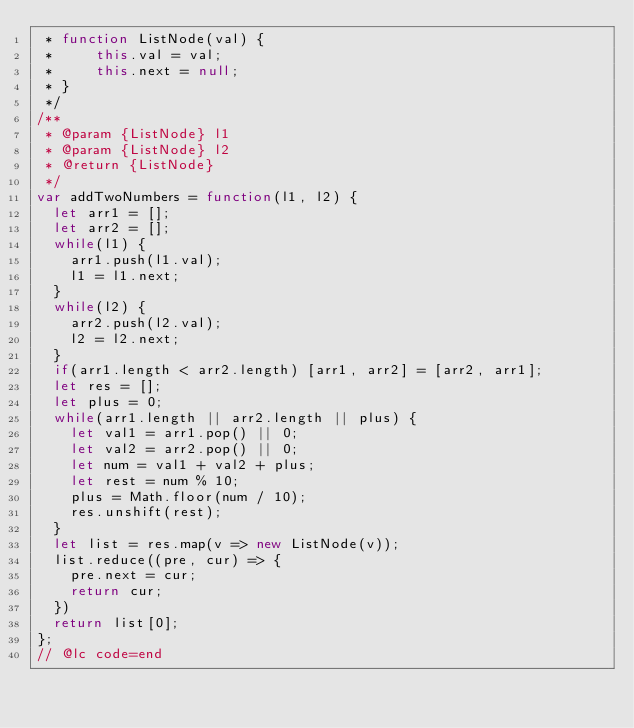<code> <loc_0><loc_0><loc_500><loc_500><_JavaScript_> * function ListNode(val) {
 *     this.val = val;
 *     this.next = null;
 * }
 */
/**
 * @param {ListNode} l1
 * @param {ListNode} l2
 * @return {ListNode}
 */
var addTwoNumbers = function(l1, l2) {
  let arr1 = [];
  let arr2 = [];
  while(l1) {
    arr1.push(l1.val);
    l1 = l1.next;
  }
  while(l2) {
    arr2.push(l2.val);
    l2 = l2.next;
  }
  if(arr1.length < arr2.length) [arr1, arr2] = [arr2, arr1];
  let res = [];
  let plus = 0;
  while(arr1.length || arr2.length || plus) {
    let val1 = arr1.pop() || 0;
    let val2 = arr2.pop() || 0;
    let num = val1 + val2 + plus;
    let rest = num % 10;
    plus = Math.floor(num / 10);
    res.unshift(rest);
  }
  let list = res.map(v => new ListNode(v));
  list.reduce((pre, cur) => {
    pre.next = cur;
    return cur;
  })
  return list[0];
};
// @lc code=end

</code> 